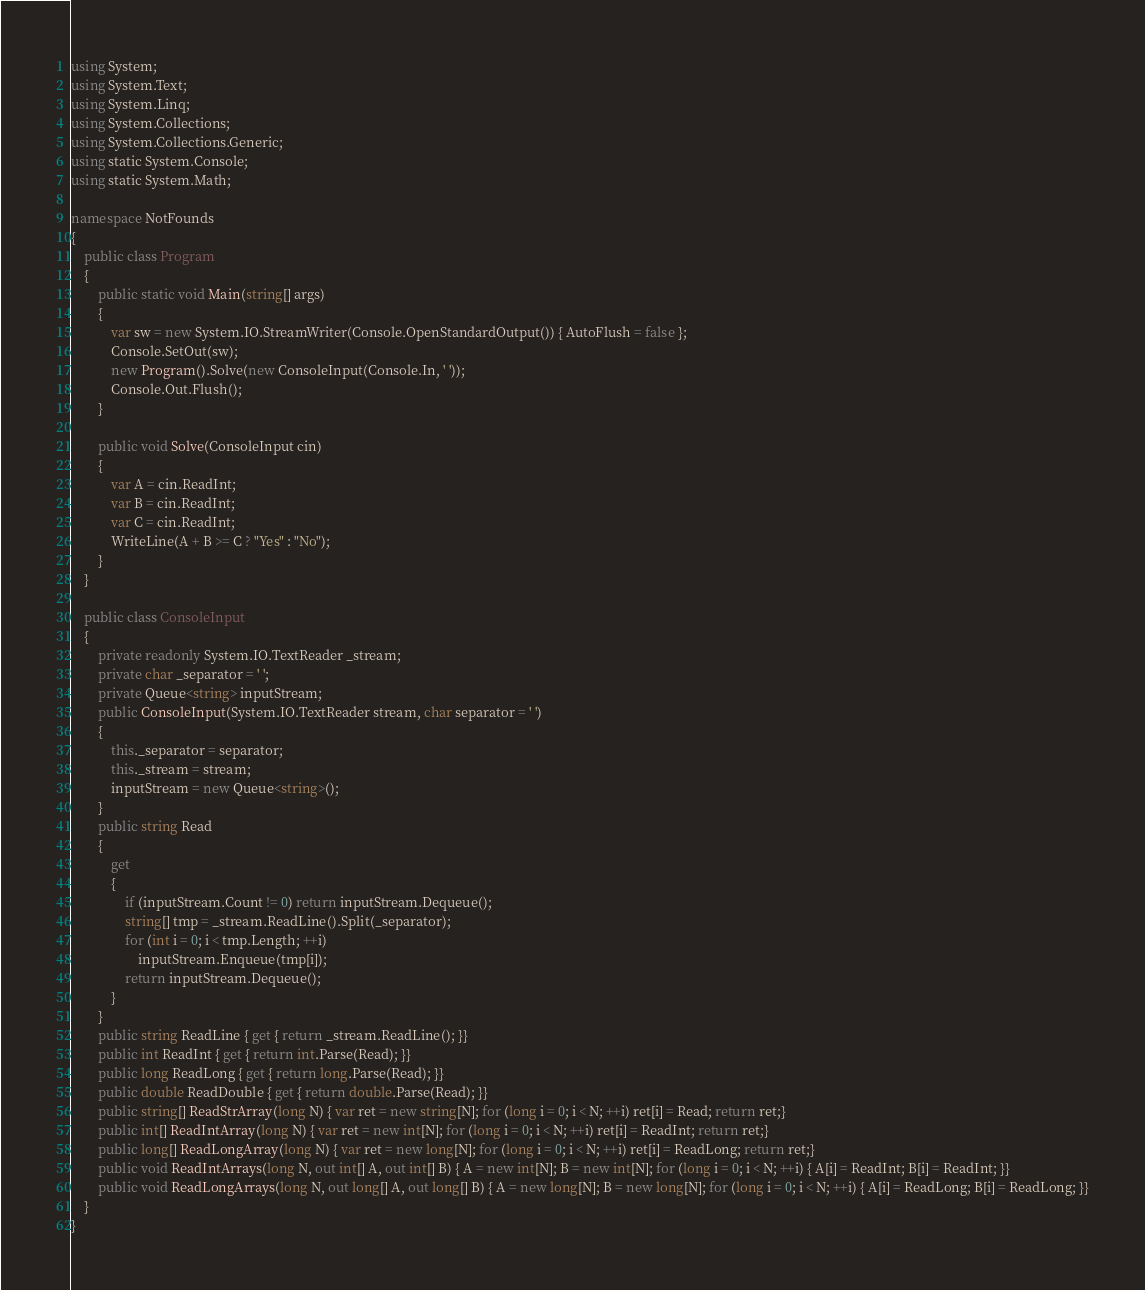Convert code to text. <code><loc_0><loc_0><loc_500><loc_500><_C#_>using System;
using System.Text;
using System.Linq;
using System.Collections;
using System.Collections.Generic;
using static System.Console;
using static System.Math;

namespace NotFounds
{
    public class Program
    {
        public static void Main(string[] args)
        {
            var sw = new System.IO.StreamWriter(Console.OpenStandardOutput()) { AutoFlush = false };
            Console.SetOut(sw);
            new Program().Solve(new ConsoleInput(Console.In, ' '));
            Console.Out.Flush();
        }

        public void Solve(ConsoleInput cin)
        {
            var A = cin.ReadInt;
            var B = cin.ReadInt;
            var C = cin.ReadInt;
            WriteLine(A + B >= C ? "Yes" : "No");
        }
    }

    public class ConsoleInput
    {
        private readonly System.IO.TextReader _stream;
        private char _separator = ' ';
        private Queue<string> inputStream;
        public ConsoleInput(System.IO.TextReader stream, char separator = ' ')
        {
            this._separator = separator;
            this._stream = stream;
            inputStream = new Queue<string>();
        }
        public string Read
        {
            get
            {
                if (inputStream.Count != 0) return inputStream.Dequeue();
                string[] tmp = _stream.ReadLine().Split(_separator);
                for (int i = 0; i < tmp.Length; ++i)
                    inputStream.Enqueue(tmp[i]);
                return inputStream.Dequeue();
            }
        }
        public string ReadLine { get { return _stream.ReadLine(); }}
        public int ReadInt { get { return int.Parse(Read); }}
        public long ReadLong { get { return long.Parse(Read); }}
        public double ReadDouble { get { return double.Parse(Read); }}
        public string[] ReadStrArray(long N) { var ret = new string[N]; for (long i = 0; i < N; ++i) ret[i] = Read; return ret;}
        public int[] ReadIntArray(long N) { var ret = new int[N]; for (long i = 0; i < N; ++i) ret[i] = ReadInt; return ret;}
        public long[] ReadLongArray(long N) { var ret = new long[N]; for (long i = 0; i < N; ++i) ret[i] = ReadLong; return ret;}
        public void ReadIntArrays(long N, out int[] A, out int[] B) { A = new int[N]; B = new int[N]; for (long i = 0; i < N; ++i) { A[i] = ReadInt; B[i] = ReadInt; }}
        public void ReadLongArrays(long N, out long[] A, out long[] B) { A = new long[N]; B = new long[N]; for (long i = 0; i < N; ++i) { A[i] = ReadLong; B[i] = ReadLong; }}
    }
}
</code> 